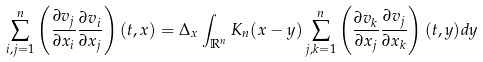<formula> <loc_0><loc_0><loc_500><loc_500>\sum _ { i , j = 1 } ^ { n } \left ( \frac { \partial v _ { j } } { \partial x _ { i } } \frac { \partial v _ { i } } { \partial x _ { j } } \right ) ( t , x ) = \Delta _ { x } \int _ { { \mathbb { R } } ^ { n } } K _ { n } ( x - y ) \sum _ { j , k = 1 } ^ { n } \left ( \frac { \partial v _ { k } } { \partial x _ { j } } \frac { \partial v _ { j } } { \partial x _ { k } } \right ) ( t , y ) d y</formula> 